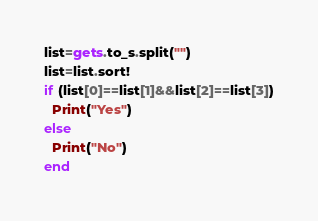Convert code to text. <code><loc_0><loc_0><loc_500><loc_500><_Ruby_>list=gets.to_s.split("")
list=list.sort!
if (list[0]==list[1]&&list[2]==list[3])
  Print("Yes")
else
  Print("No")
end</code> 